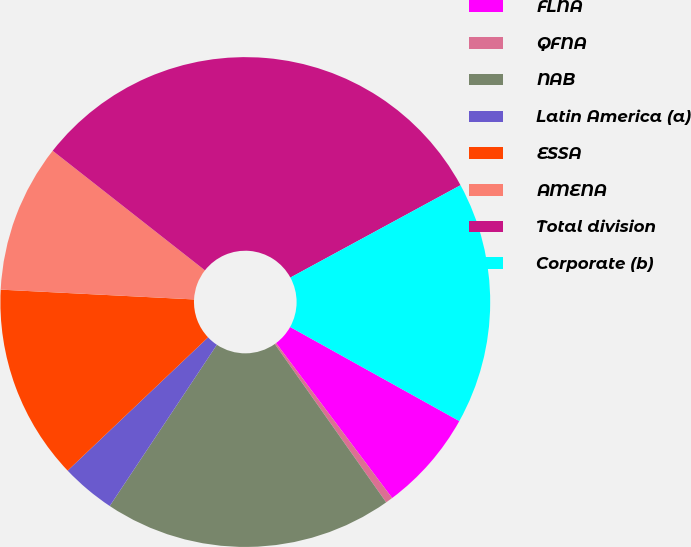Convert chart to OTSL. <chart><loc_0><loc_0><loc_500><loc_500><pie_chart><fcel>FLNA<fcel>QFNA<fcel>NAB<fcel>Latin America (a)<fcel>ESSA<fcel>AMENA<fcel>Total division<fcel>Corporate (b)<nl><fcel>6.69%<fcel>0.48%<fcel>19.09%<fcel>3.58%<fcel>12.89%<fcel>9.79%<fcel>31.49%<fcel>15.99%<nl></chart> 